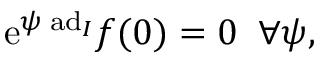<formula> <loc_0><loc_0><loc_500><loc_500>e ^ { \psi \, a d _ { I } } f ( 0 ) = 0 \, \forall \psi ,</formula> 